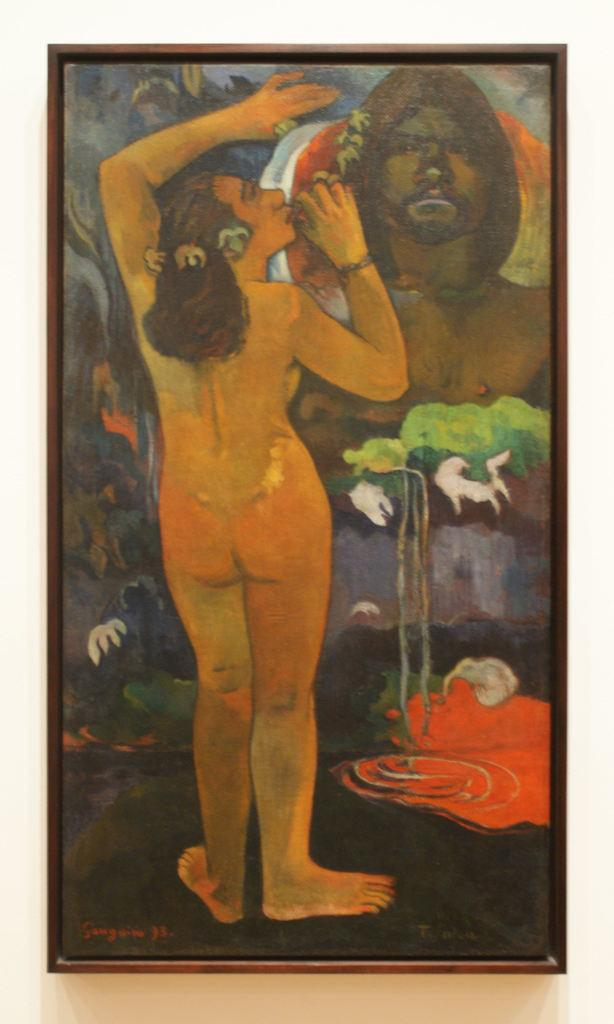What is the main subject of the image? The main subject of the image is a painting. What is depicted in the painting? The painting depicts two persons. Are there any other elements in the painting besides the two persons? Yes, there is a tree in the painting. Is there a camp visible in the painting? There is no camp present in the painting; it depicts two persons and a tree. 